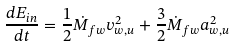<formula> <loc_0><loc_0><loc_500><loc_500>\frac { d E _ { i n } } { d t } = \frac { 1 } { 2 } \dot { M } _ { f w } v _ { w , u } ^ { 2 } + \frac { 3 } { 2 } \dot { M } _ { f w } a _ { w , u } ^ { 2 }</formula> 